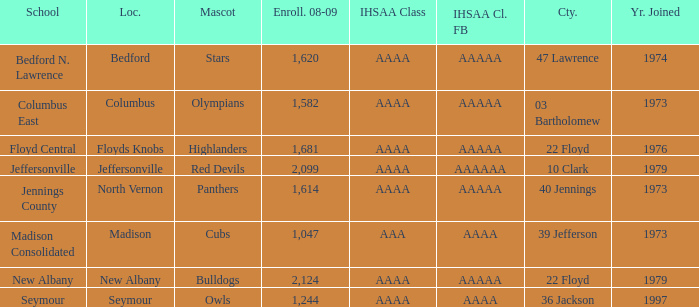What's the IHSAA Class Football if the panthers are the mascot? AAAAA. 